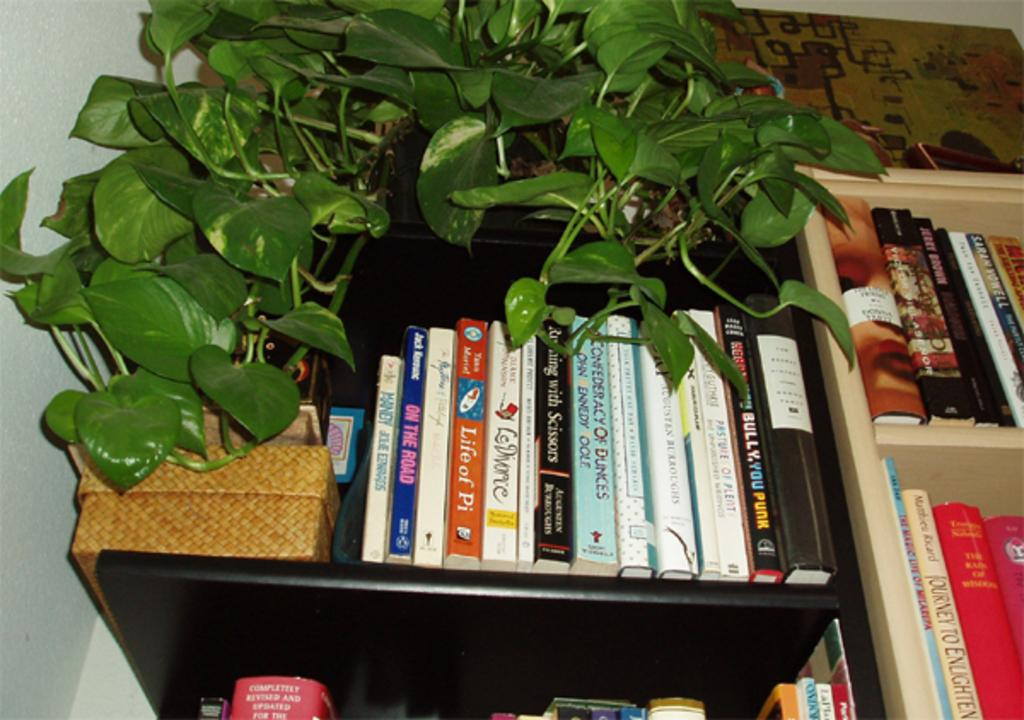What is the main subject in the center of the image? There are books arranged in a rack in the center of the image. Are there any plants visible in the image? Yes, there is a money plant in the image. What can be seen on the left side of the image? There is a wall to the left side of the image. What type of doll is sitting on the wall in the image? There is no doll present in the image; it only features books arranged in a rack, a money plant, and a wall. 